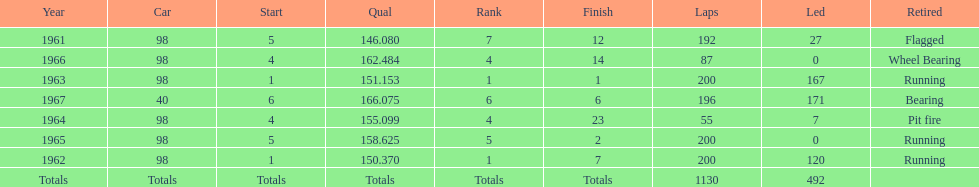In how many indy 500 races, has jones been flagged? 1. 